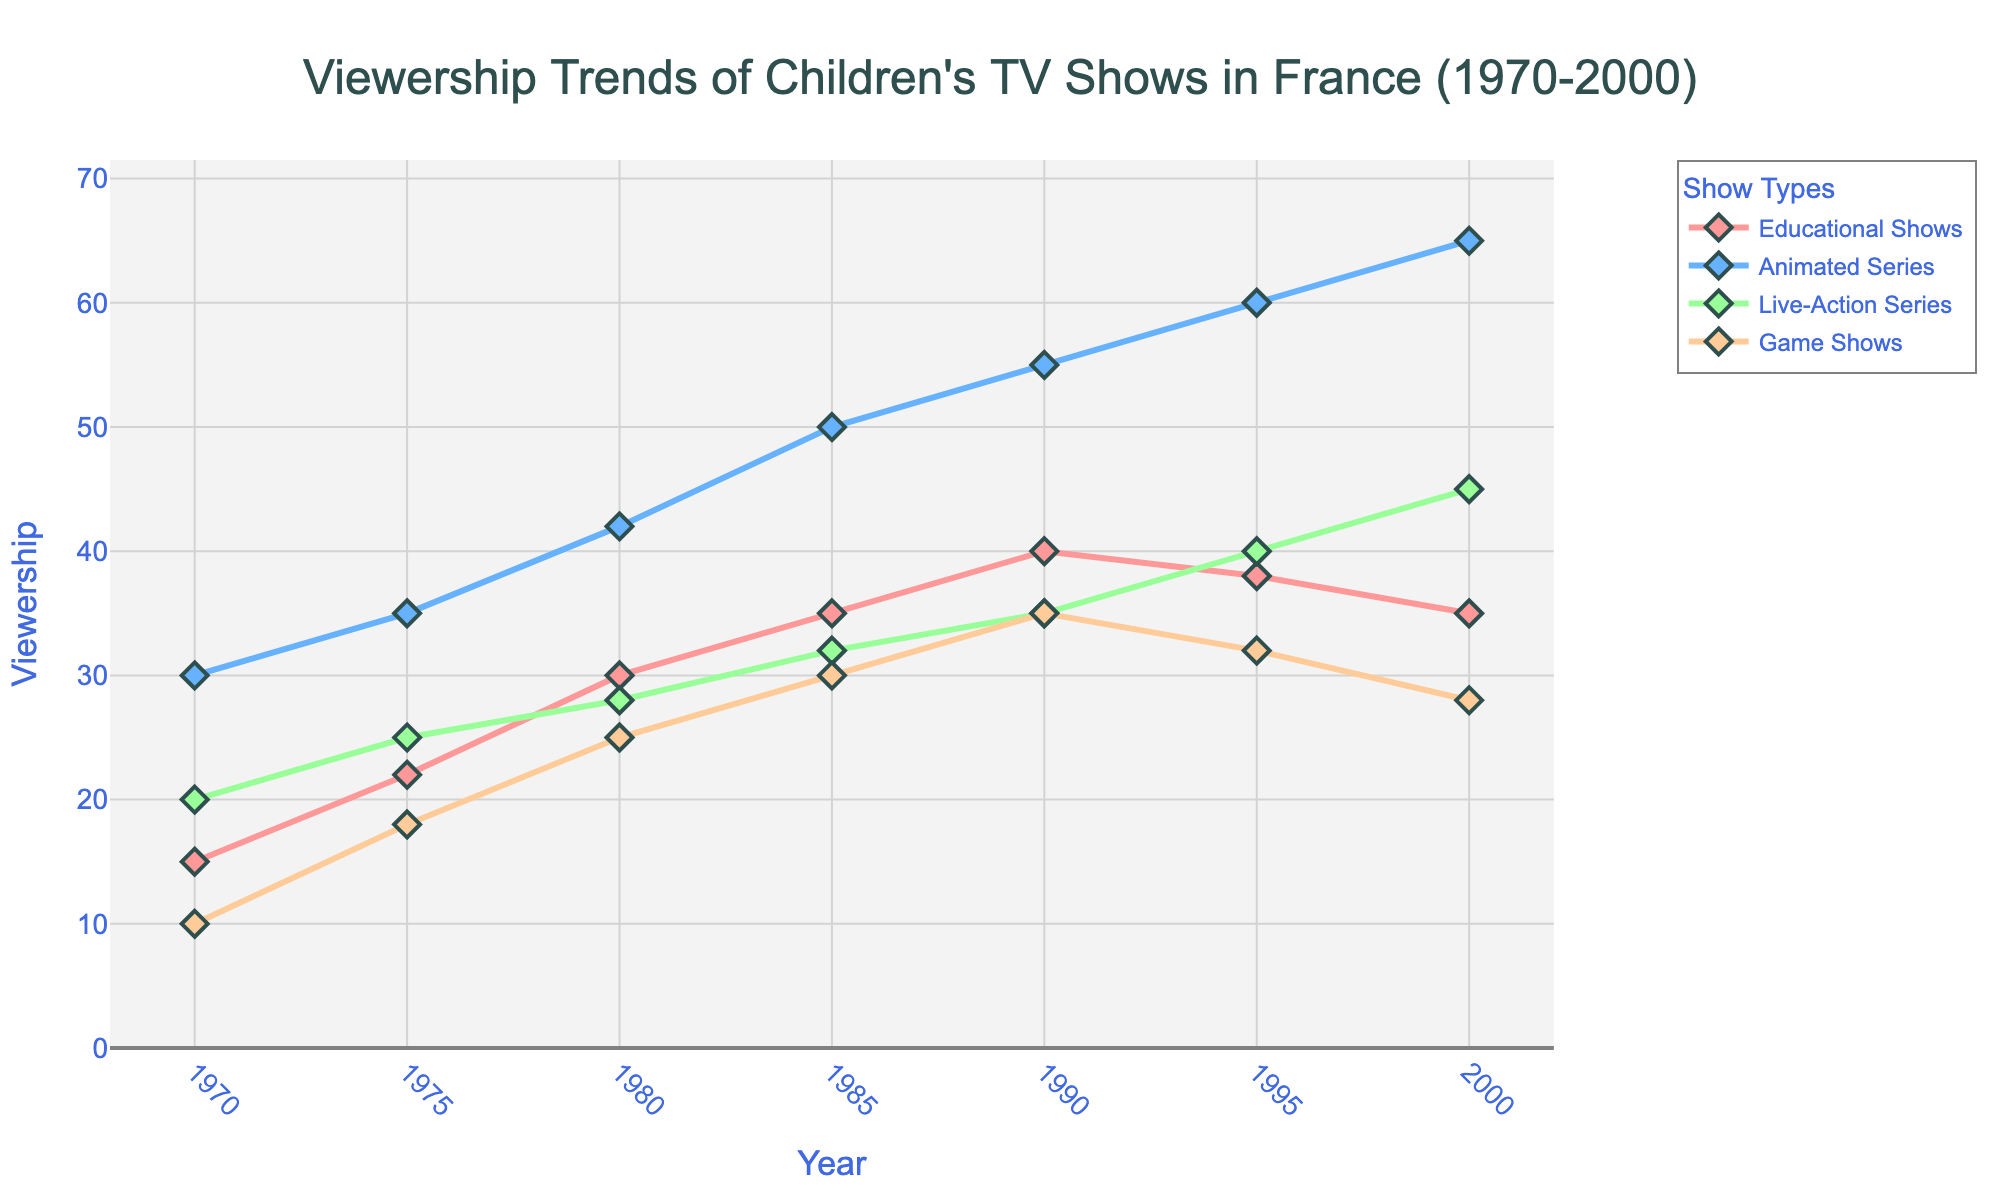What year did Animated Series first surpass 50 viewership? To find the answer, identify when Animated Series first reached a viewership of over 50 by examining the values of the Animated Series line. In 1985, it first surpassed 50 with a viewership of 50.
Answer: 1985 Which show type had the highest viewership in 1995? To determine this, compare the viewership of each show type in 1995. Animated Series had the highest viewership with 60.
Answer: Animated Series How did the viewership of Educational Shows change from 1970 to 2000? Examine the starting and ending points of the Educational Shows line. In 1970, the viewership was 15, and in 2000, it dropped to 35. This shows an increase in viewership.
Answer: Increased by 20 What is the difference in viewership between Animated Series and Live-Action Series in 2000? Find the viewership values for both show types in the year 2000 and subtract the Live-Action Series value from the Animated Series value. The difference is 65 - 45 = 20.
Answer: 20 Which show type had the most consistent growth between 1970 and 2000? To identify this, look for the show type with the steadiest increase over the years. Animated Series shows consistent growth every five years from 1970 to 2000.
Answer: Animated Series In 1980, what was the sum of the viewership for all show types? Add the viewership values of all show types in 1980: 30 (Educational Shows) + 42 (Animated Series) + 28 (Live-Action Series) + 25 (Game Shows). The sum is 125.
Answer: 125 Between 1990 and 1995, which show type saw a decrease in viewership? Look at the data points for each show type between 1990 and 1995. Educational Shows decreased from 40 to 38, and Game Shows decreased from 35 to 32.
Answer: Educational Shows, Game Shows What is the average viewership of Game Shows from 1985 to 2000? Add the viewership values of Game Shows from 1985 to 2000: 30 (1985) + 35 (1990) + 32 (1995) + 28 (2000). Divide the sum by the number of years (4). The average is (30 + 35 + 32 + 28) / 4 = 31.25.
Answer: 31.25 In which decade did Live-Action Series see the highest increase in viewership? Calculate the difference in viewership for each decade: 1970-1980 (28-20=8), 1980-1990 (35-28=7), 1990-2000 (45-35=10). The highest increase occurred in the 1990s with a 10 viewership increase.
Answer: 1990s Which line is represented by the green color in the chart? Observe the colors of the lines in the chart and identify the one that is green. Green represents Live-Action Series.
Answer: Live-Action Series 